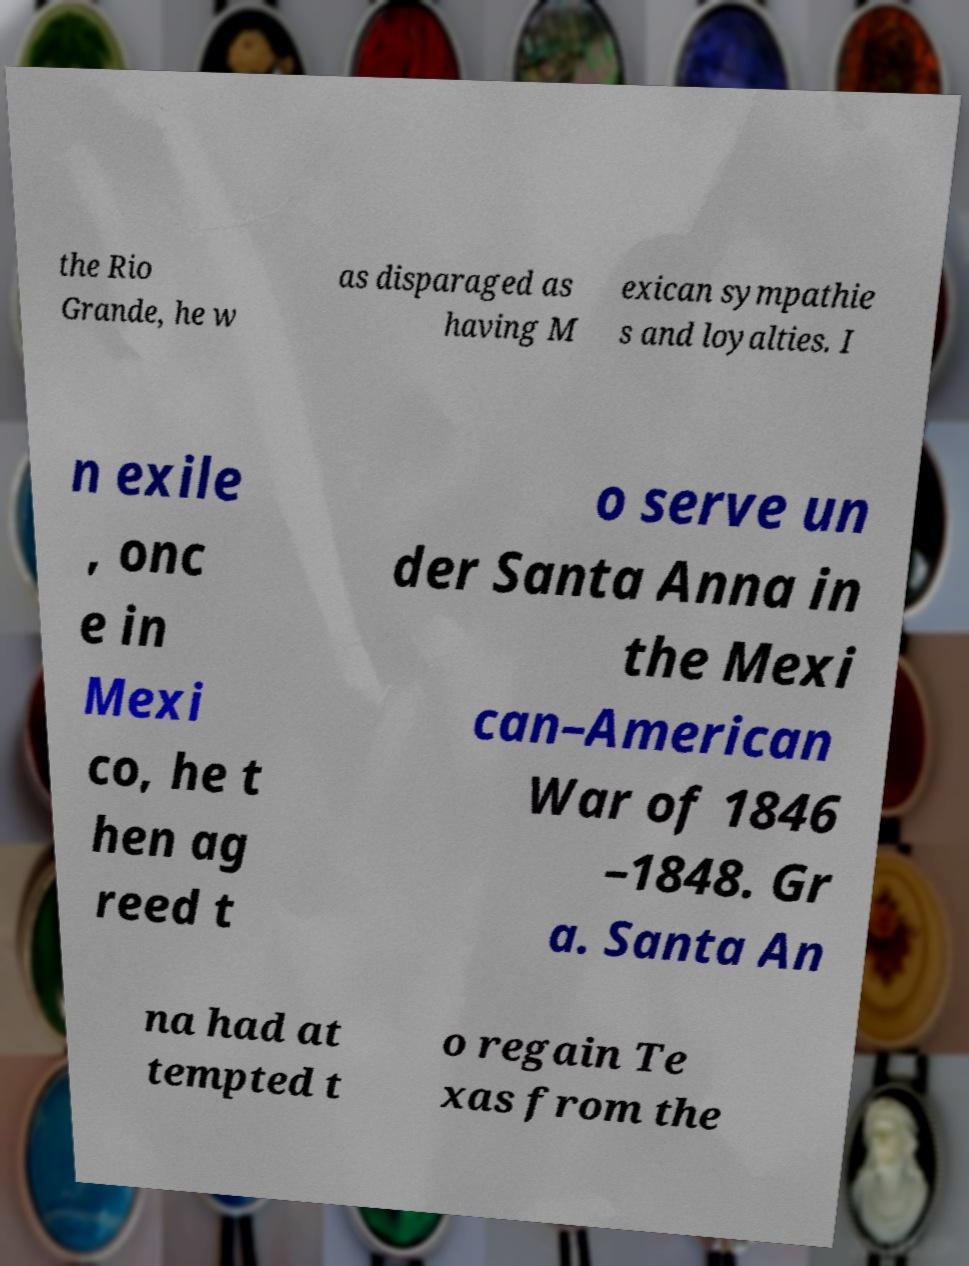Could you assist in decoding the text presented in this image and type it out clearly? the Rio Grande, he w as disparaged as having M exican sympathie s and loyalties. I n exile , onc e in Mexi co, he t hen ag reed t o serve un der Santa Anna in the Mexi can–American War of 1846 –1848. Gr a. Santa An na had at tempted t o regain Te xas from the 